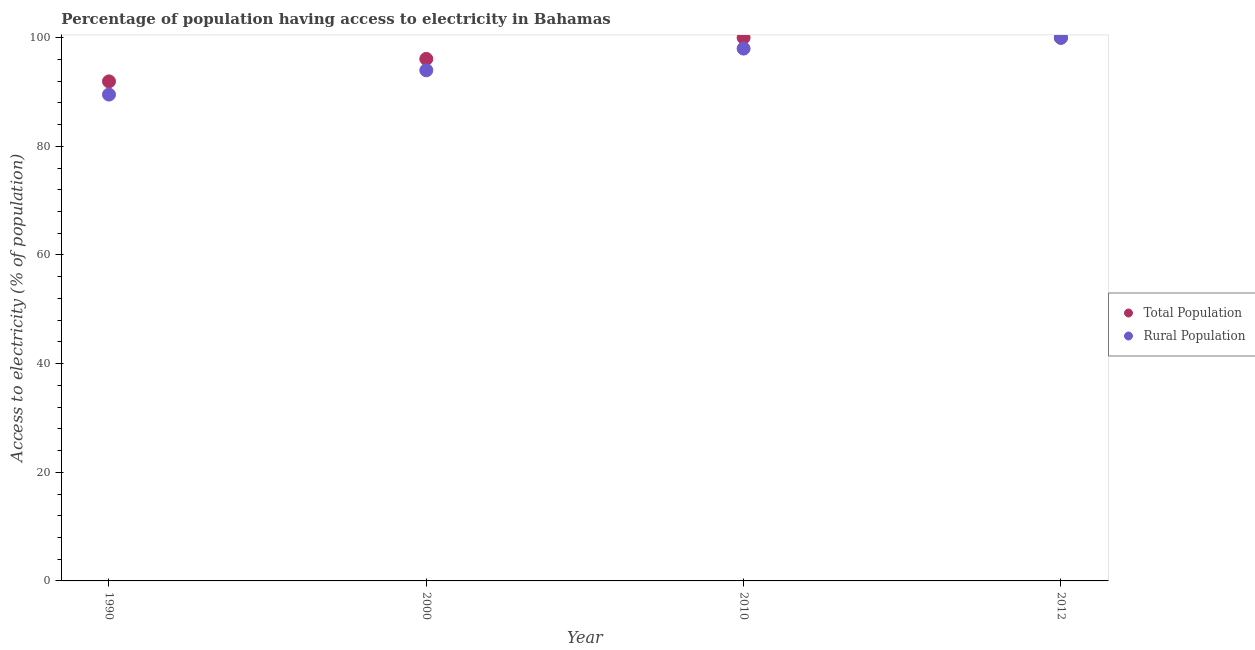How many different coloured dotlines are there?
Your response must be concise. 2. What is the percentage of rural population having access to electricity in 1990?
Your answer should be very brief. 89.53. Across all years, what is the maximum percentage of rural population having access to electricity?
Provide a short and direct response. 100. Across all years, what is the minimum percentage of population having access to electricity?
Ensure brevity in your answer.  91.96. In which year was the percentage of population having access to electricity minimum?
Provide a short and direct response. 1990. What is the total percentage of population having access to electricity in the graph?
Provide a short and direct response. 388.06. What is the difference between the percentage of rural population having access to electricity in 2010 and the percentage of population having access to electricity in 2000?
Keep it short and to the point. 1.9. What is the average percentage of population having access to electricity per year?
Make the answer very short. 97.02. In the year 2000, what is the difference between the percentage of rural population having access to electricity and percentage of population having access to electricity?
Provide a short and direct response. -2.1. What is the ratio of the percentage of population having access to electricity in 1990 to that in 2010?
Your response must be concise. 0.92. Is the percentage of population having access to electricity in 1990 less than that in 2012?
Offer a terse response. Yes. What is the difference between the highest and the second highest percentage of rural population having access to electricity?
Provide a short and direct response. 2. What is the difference between the highest and the lowest percentage of rural population having access to electricity?
Your answer should be compact. 10.47. In how many years, is the percentage of rural population having access to electricity greater than the average percentage of rural population having access to electricity taken over all years?
Provide a short and direct response. 2. Is the sum of the percentage of population having access to electricity in 2010 and 2012 greater than the maximum percentage of rural population having access to electricity across all years?
Offer a very short reply. Yes. Does the percentage of population having access to electricity monotonically increase over the years?
Your answer should be compact. No. What is the difference between two consecutive major ticks on the Y-axis?
Make the answer very short. 20. Does the graph contain any zero values?
Make the answer very short. No. Does the graph contain grids?
Offer a very short reply. No. Where does the legend appear in the graph?
Provide a short and direct response. Center right. What is the title of the graph?
Give a very brief answer. Percentage of population having access to electricity in Bahamas. What is the label or title of the X-axis?
Provide a succinct answer. Year. What is the label or title of the Y-axis?
Give a very brief answer. Access to electricity (% of population). What is the Access to electricity (% of population) in Total Population in 1990?
Keep it short and to the point. 91.96. What is the Access to electricity (% of population) in Rural Population in 1990?
Ensure brevity in your answer.  89.53. What is the Access to electricity (% of population) of Total Population in 2000?
Your response must be concise. 96.1. What is the Access to electricity (% of population) in Rural Population in 2000?
Offer a very short reply. 94. What is the Access to electricity (% of population) in Total Population in 2010?
Your answer should be very brief. 100. What is the Access to electricity (% of population) of Rural Population in 2010?
Ensure brevity in your answer.  98. What is the Access to electricity (% of population) in Total Population in 2012?
Your answer should be very brief. 100. Across all years, what is the maximum Access to electricity (% of population) in Rural Population?
Your answer should be very brief. 100. Across all years, what is the minimum Access to electricity (% of population) of Total Population?
Provide a succinct answer. 91.96. Across all years, what is the minimum Access to electricity (% of population) in Rural Population?
Make the answer very short. 89.53. What is the total Access to electricity (% of population) of Total Population in the graph?
Provide a short and direct response. 388.06. What is the total Access to electricity (% of population) of Rural Population in the graph?
Make the answer very short. 381.53. What is the difference between the Access to electricity (% of population) in Total Population in 1990 and that in 2000?
Offer a very short reply. -4.14. What is the difference between the Access to electricity (% of population) of Rural Population in 1990 and that in 2000?
Your answer should be very brief. -4.47. What is the difference between the Access to electricity (% of population) in Total Population in 1990 and that in 2010?
Give a very brief answer. -8.04. What is the difference between the Access to electricity (% of population) in Rural Population in 1990 and that in 2010?
Ensure brevity in your answer.  -8.47. What is the difference between the Access to electricity (% of population) of Total Population in 1990 and that in 2012?
Make the answer very short. -8.04. What is the difference between the Access to electricity (% of population) of Rural Population in 1990 and that in 2012?
Offer a very short reply. -10.47. What is the difference between the Access to electricity (% of population) in Rural Population in 2000 and that in 2010?
Offer a very short reply. -4. What is the difference between the Access to electricity (% of population) in Total Population in 2010 and that in 2012?
Keep it short and to the point. 0. What is the difference between the Access to electricity (% of population) in Rural Population in 2010 and that in 2012?
Your response must be concise. -2. What is the difference between the Access to electricity (% of population) in Total Population in 1990 and the Access to electricity (% of population) in Rural Population in 2000?
Offer a very short reply. -2.04. What is the difference between the Access to electricity (% of population) in Total Population in 1990 and the Access to electricity (% of population) in Rural Population in 2010?
Make the answer very short. -6.04. What is the difference between the Access to electricity (% of population) in Total Population in 1990 and the Access to electricity (% of population) in Rural Population in 2012?
Give a very brief answer. -8.04. What is the difference between the Access to electricity (% of population) in Total Population in 2010 and the Access to electricity (% of population) in Rural Population in 2012?
Offer a terse response. 0. What is the average Access to electricity (% of population) in Total Population per year?
Your response must be concise. 97.02. What is the average Access to electricity (% of population) of Rural Population per year?
Provide a succinct answer. 95.38. In the year 1990, what is the difference between the Access to electricity (% of population) of Total Population and Access to electricity (% of population) of Rural Population?
Ensure brevity in your answer.  2.43. In the year 2000, what is the difference between the Access to electricity (% of population) of Total Population and Access to electricity (% of population) of Rural Population?
Keep it short and to the point. 2.1. In the year 2010, what is the difference between the Access to electricity (% of population) of Total Population and Access to electricity (% of population) of Rural Population?
Ensure brevity in your answer.  2. In the year 2012, what is the difference between the Access to electricity (% of population) of Total Population and Access to electricity (% of population) of Rural Population?
Your answer should be very brief. 0. What is the ratio of the Access to electricity (% of population) in Total Population in 1990 to that in 2000?
Offer a terse response. 0.96. What is the ratio of the Access to electricity (% of population) in Rural Population in 1990 to that in 2000?
Your answer should be very brief. 0.95. What is the ratio of the Access to electricity (% of population) in Total Population in 1990 to that in 2010?
Provide a short and direct response. 0.92. What is the ratio of the Access to electricity (% of population) of Rural Population in 1990 to that in 2010?
Provide a succinct answer. 0.91. What is the ratio of the Access to electricity (% of population) in Total Population in 1990 to that in 2012?
Offer a very short reply. 0.92. What is the ratio of the Access to electricity (% of population) of Rural Population in 1990 to that in 2012?
Your response must be concise. 0.9. What is the ratio of the Access to electricity (% of population) in Rural Population in 2000 to that in 2010?
Make the answer very short. 0.96. What is the ratio of the Access to electricity (% of population) of Rural Population in 2000 to that in 2012?
Offer a very short reply. 0.94. What is the ratio of the Access to electricity (% of population) in Rural Population in 2010 to that in 2012?
Offer a very short reply. 0.98. What is the difference between the highest and the lowest Access to electricity (% of population) in Total Population?
Make the answer very short. 8.04. What is the difference between the highest and the lowest Access to electricity (% of population) of Rural Population?
Give a very brief answer. 10.47. 